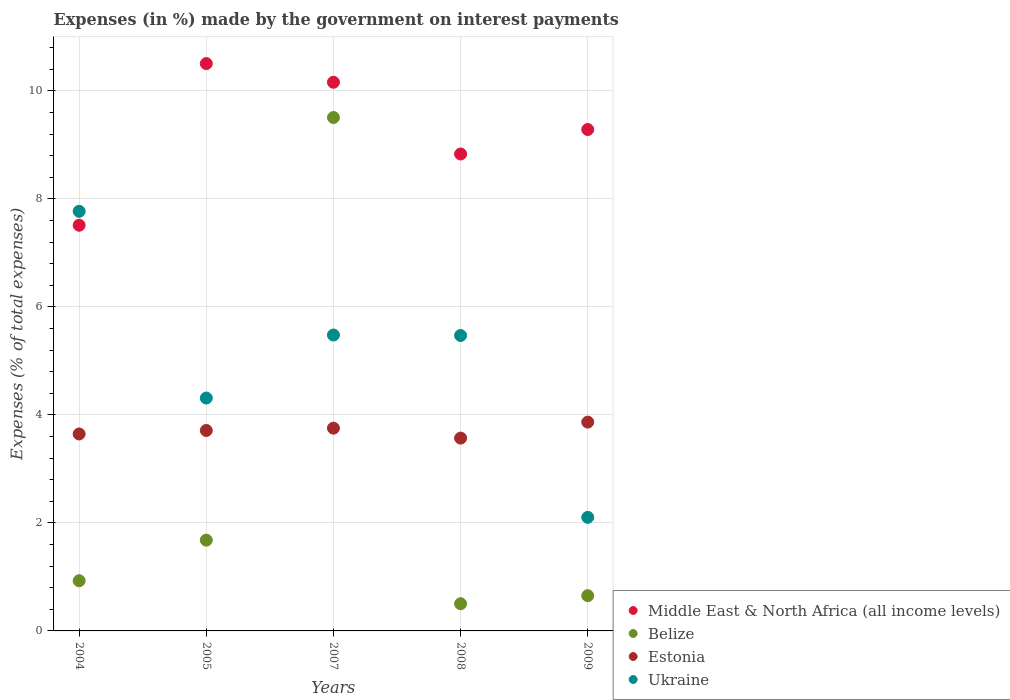Is the number of dotlines equal to the number of legend labels?
Provide a short and direct response. Yes. What is the percentage of expenses made by the government on interest payments in Ukraine in 2005?
Offer a very short reply. 4.31. Across all years, what is the maximum percentage of expenses made by the government on interest payments in Estonia?
Give a very brief answer. 3.87. Across all years, what is the minimum percentage of expenses made by the government on interest payments in Estonia?
Your response must be concise. 3.57. What is the total percentage of expenses made by the government on interest payments in Ukraine in the graph?
Offer a very short reply. 25.13. What is the difference between the percentage of expenses made by the government on interest payments in Belize in 2004 and that in 2009?
Your answer should be compact. 0.28. What is the difference between the percentage of expenses made by the government on interest payments in Ukraine in 2004 and the percentage of expenses made by the government on interest payments in Belize in 2008?
Your response must be concise. 7.27. What is the average percentage of expenses made by the government on interest payments in Ukraine per year?
Ensure brevity in your answer.  5.03. In the year 2005, what is the difference between the percentage of expenses made by the government on interest payments in Estonia and percentage of expenses made by the government on interest payments in Middle East & North Africa (all income levels)?
Your response must be concise. -6.79. What is the ratio of the percentage of expenses made by the government on interest payments in Estonia in 2005 to that in 2009?
Provide a succinct answer. 0.96. Is the percentage of expenses made by the government on interest payments in Ukraine in 2007 less than that in 2009?
Keep it short and to the point. No. What is the difference between the highest and the second highest percentage of expenses made by the government on interest payments in Estonia?
Give a very brief answer. 0.11. What is the difference between the highest and the lowest percentage of expenses made by the government on interest payments in Ukraine?
Your answer should be compact. 5.67. In how many years, is the percentage of expenses made by the government on interest payments in Belize greater than the average percentage of expenses made by the government on interest payments in Belize taken over all years?
Provide a short and direct response. 1. Is it the case that in every year, the sum of the percentage of expenses made by the government on interest payments in Middle East & North Africa (all income levels) and percentage of expenses made by the government on interest payments in Estonia  is greater than the sum of percentage of expenses made by the government on interest payments in Ukraine and percentage of expenses made by the government on interest payments in Belize?
Give a very brief answer. No. Is it the case that in every year, the sum of the percentage of expenses made by the government on interest payments in Belize and percentage of expenses made by the government on interest payments in Ukraine  is greater than the percentage of expenses made by the government on interest payments in Middle East & North Africa (all income levels)?
Ensure brevity in your answer.  No. Is the percentage of expenses made by the government on interest payments in Middle East & North Africa (all income levels) strictly greater than the percentage of expenses made by the government on interest payments in Ukraine over the years?
Make the answer very short. No. Is the percentage of expenses made by the government on interest payments in Belize strictly less than the percentage of expenses made by the government on interest payments in Middle East & North Africa (all income levels) over the years?
Your answer should be very brief. Yes. How many dotlines are there?
Your response must be concise. 4. How many years are there in the graph?
Offer a terse response. 5. What is the difference between two consecutive major ticks on the Y-axis?
Make the answer very short. 2. Are the values on the major ticks of Y-axis written in scientific E-notation?
Your answer should be compact. No. Where does the legend appear in the graph?
Your answer should be very brief. Bottom right. How are the legend labels stacked?
Give a very brief answer. Vertical. What is the title of the graph?
Ensure brevity in your answer.  Expenses (in %) made by the government on interest payments. What is the label or title of the X-axis?
Offer a terse response. Years. What is the label or title of the Y-axis?
Your response must be concise. Expenses (% of total expenses). What is the Expenses (% of total expenses) in Middle East & North Africa (all income levels) in 2004?
Ensure brevity in your answer.  7.51. What is the Expenses (% of total expenses) in Belize in 2004?
Your response must be concise. 0.93. What is the Expenses (% of total expenses) in Estonia in 2004?
Your answer should be very brief. 3.65. What is the Expenses (% of total expenses) in Ukraine in 2004?
Your response must be concise. 7.77. What is the Expenses (% of total expenses) of Middle East & North Africa (all income levels) in 2005?
Your answer should be very brief. 10.5. What is the Expenses (% of total expenses) of Belize in 2005?
Provide a succinct answer. 1.68. What is the Expenses (% of total expenses) of Estonia in 2005?
Make the answer very short. 3.71. What is the Expenses (% of total expenses) in Ukraine in 2005?
Provide a succinct answer. 4.31. What is the Expenses (% of total expenses) of Middle East & North Africa (all income levels) in 2007?
Your response must be concise. 10.16. What is the Expenses (% of total expenses) of Belize in 2007?
Your response must be concise. 9.51. What is the Expenses (% of total expenses) of Estonia in 2007?
Provide a succinct answer. 3.75. What is the Expenses (% of total expenses) in Ukraine in 2007?
Offer a terse response. 5.48. What is the Expenses (% of total expenses) in Middle East & North Africa (all income levels) in 2008?
Provide a succinct answer. 8.83. What is the Expenses (% of total expenses) in Belize in 2008?
Your response must be concise. 0.5. What is the Expenses (% of total expenses) of Estonia in 2008?
Your response must be concise. 3.57. What is the Expenses (% of total expenses) in Ukraine in 2008?
Your answer should be compact. 5.47. What is the Expenses (% of total expenses) in Middle East & North Africa (all income levels) in 2009?
Give a very brief answer. 9.28. What is the Expenses (% of total expenses) in Belize in 2009?
Make the answer very short. 0.65. What is the Expenses (% of total expenses) of Estonia in 2009?
Your answer should be compact. 3.87. What is the Expenses (% of total expenses) in Ukraine in 2009?
Your response must be concise. 2.1. Across all years, what is the maximum Expenses (% of total expenses) of Middle East & North Africa (all income levels)?
Make the answer very short. 10.5. Across all years, what is the maximum Expenses (% of total expenses) of Belize?
Make the answer very short. 9.51. Across all years, what is the maximum Expenses (% of total expenses) of Estonia?
Keep it short and to the point. 3.87. Across all years, what is the maximum Expenses (% of total expenses) of Ukraine?
Ensure brevity in your answer.  7.77. Across all years, what is the minimum Expenses (% of total expenses) in Middle East & North Africa (all income levels)?
Your response must be concise. 7.51. Across all years, what is the minimum Expenses (% of total expenses) of Belize?
Offer a very short reply. 0.5. Across all years, what is the minimum Expenses (% of total expenses) of Estonia?
Your answer should be very brief. 3.57. Across all years, what is the minimum Expenses (% of total expenses) of Ukraine?
Provide a succinct answer. 2.1. What is the total Expenses (% of total expenses) of Middle East & North Africa (all income levels) in the graph?
Make the answer very short. 46.29. What is the total Expenses (% of total expenses) of Belize in the graph?
Your answer should be very brief. 13.27. What is the total Expenses (% of total expenses) of Estonia in the graph?
Give a very brief answer. 18.55. What is the total Expenses (% of total expenses) in Ukraine in the graph?
Your answer should be very brief. 25.13. What is the difference between the Expenses (% of total expenses) in Middle East & North Africa (all income levels) in 2004 and that in 2005?
Offer a terse response. -2.99. What is the difference between the Expenses (% of total expenses) of Belize in 2004 and that in 2005?
Your answer should be very brief. -0.75. What is the difference between the Expenses (% of total expenses) of Estonia in 2004 and that in 2005?
Give a very brief answer. -0.06. What is the difference between the Expenses (% of total expenses) in Ukraine in 2004 and that in 2005?
Your answer should be compact. 3.46. What is the difference between the Expenses (% of total expenses) in Middle East & North Africa (all income levels) in 2004 and that in 2007?
Your answer should be very brief. -2.65. What is the difference between the Expenses (% of total expenses) of Belize in 2004 and that in 2007?
Offer a terse response. -8.58. What is the difference between the Expenses (% of total expenses) in Estonia in 2004 and that in 2007?
Your answer should be very brief. -0.11. What is the difference between the Expenses (% of total expenses) of Ukraine in 2004 and that in 2007?
Offer a terse response. 2.29. What is the difference between the Expenses (% of total expenses) in Middle East & North Africa (all income levels) in 2004 and that in 2008?
Keep it short and to the point. -1.32. What is the difference between the Expenses (% of total expenses) in Belize in 2004 and that in 2008?
Offer a terse response. 0.43. What is the difference between the Expenses (% of total expenses) of Estonia in 2004 and that in 2008?
Your response must be concise. 0.08. What is the difference between the Expenses (% of total expenses) of Ukraine in 2004 and that in 2008?
Your response must be concise. 2.3. What is the difference between the Expenses (% of total expenses) in Middle East & North Africa (all income levels) in 2004 and that in 2009?
Ensure brevity in your answer.  -1.77. What is the difference between the Expenses (% of total expenses) of Belize in 2004 and that in 2009?
Offer a terse response. 0.28. What is the difference between the Expenses (% of total expenses) in Estonia in 2004 and that in 2009?
Offer a very short reply. -0.22. What is the difference between the Expenses (% of total expenses) in Ukraine in 2004 and that in 2009?
Your response must be concise. 5.67. What is the difference between the Expenses (% of total expenses) of Middle East & North Africa (all income levels) in 2005 and that in 2007?
Your answer should be very brief. 0.35. What is the difference between the Expenses (% of total expenses) of Belize in 2005 and that in 2007?
Offer a terse response. -7.83. What is the difference between the Expenses (% of total expenses) in Estonia in 2005 and that in 2007?
Your answer should be compact. -0.04. What is the difference between the Expenses (% of total expenses) of Ukraine in 2005 and that in 2007?
Your answer should be compact. -1.17. What is the difference between the Expenses (% of total expenses) of Middle East & North Africa (all income levels) in 2005 and that in 2008?
Your answer should be compact. 1.67. What is the difference between the Expenses (% of total expenses) of Belize in 2005 and that in 2008?
Ensure brevity in your answer.  1.18. What is the difference between the Expenses (% of total expenses) in Estonia in 2005 and that in 2008?
Provide a succinct answer. 0.14. What is the difference between the Expenses (% of total expenses) of Ukraine in 2005 and that in 2008?
Keep it short and to the point. -1.16. What is the difference between the Expenses (% of total expenses) in Middle East & North Africa (all income levels) in 2005 and that in 2009?
Offer a very short reply. 1.22. What is the difference between the Expenses (% of total expenses) of Belize in 2005 and that in 2009?
Provide a succinct answer. 1.03. What is the difference between the Expenses (% of total expenses) in Estonia in 2005 and that in 2009?
Provide a succinct answer. -0.15. What is the difference between the Expenses (% of total expenses) in Ukraine in 2005 and that in 2009?
Give a very brief answer. 2.21. What is the difference between the Expenses (% of total expenses) in Middle East & North Africa (all income levels) in 2007 and that in 2008?
Give a very brief answer. 1.33. What is the difference between the Expenses (% of total expenses) in Belize in 2007 and that in 2008?
Give a very brief answer. 9. What is the difference between the Expenses (% of total expenses) of Estonia in 2007 and that in 2008?
Your answer should be compact. 0.18. What is the difference between the Expenses (% of total expenses) in Ukraine in 2007 and that in 2008?
Provide a short and direct response. 0.01. What is the difference between the Expenses (% of total expenses) of Middle East & North Africa (all income levels) in 2007 and that in 2009?
Offer a terse response. 0.87. What is the difference between the Expenses (% of total expenses) of Belize in 2007 and that in 2009?
Give a very brief answer. 8.85. What is the difference between the Expenses (% of total expenses) of Estonia in 2007 and that in 2009?
Provide a short and direct response. -0.11. What is the difference between the Expenses (% of total expenses) of Ukraine in 2007 and that in 2009?
Make the answer very short. 3.38. What is the difference between the Expenses (% of total expenses) of Middle East & North Africa (all income levels) in 2008 and that in 2009?
Keep it short and to the point. -0.45. What is the difference between the Expenses (% of total expenses) of Belize in 2008 and that in 2009?
Make the answer very short. -0.15. What is the difference between the Expenses (% of total expenses) in Estonia in 2008 and that in 2009?
Keep it short and to the point. -0.3. What is the difference between the Expenses (% of total expenses) in Ukraine in 2008 and that in 2009?
Your answer should be very brief. 3.37. What is the difference between the Expenses (% of total expenses) of Middle East & North Africa (all income levels) in 2004 and the Expenses (% of total expenses) of Belize in 2005?
Make the answer very short. 5.83. What is the difference between the Expenses (% of total expenses) of Middle East & North Africa (all income levels) in 2004 and the Expenses (% of total expenses) of Estonia in 2005?
Provide a succinct answer. 3.8. What is the difference between the Expenses (% of total expenses) in Middle East & North Africa (all income levels) in 2004 and the Expenses (% of total expenses) in Ukraine in 2005?
Ensure brevity in your answer.  3.2. What is the difference between the Expenses (% of total expenses) in Belize in 2004 and the Expenses (% of total expenses) in Estonia in 2005?
Offer a very short reply. -2.78. What is the difference between the Expenses (% of total expenses) of Belize in 2004 and the Expenses (% of total expenses) of Ukraine in 2005?
Give a very brief answer. -3.38. What is the difference between the Expenses (% of total expenses) of Estonia in 2004 and the Expenses (% of total expenses) of Ukraine in 2005?
Make the answer very short. -0.67. What is the difference between the Expenses (% of total expenses) of Middle East & North Africa (all income levels) in 2004 and the Expenses (% of total expenses) of Belize in 2007?
Keep it short and to the point. -1.99. What is the difference between the Expenses (% of total expenses) of Middle East & North Africa (all income levels) in 2004 and the Expenses (% of total expenses) of Estonia in 2007?
Your answer should be compact. 3.76. What is the difference between the Expenses (% of total expenses) of Middle East & North Africa (all income levels) in 2004 and the Expenses (% of total expenses) of Ukraine in 2007?
Your answer should be compact. 2.03. What is the difference between the Expenses (% of total expenses) in Belize in 2004 and the Expenses (% of total expenses) in Estonia in 2007?
Provide a short and direct response. -2.82. What is the difference between the Expenses (% of total expenses) in Belize in 2004 and the Expenses (% of total expenses) in Ukraine in 2007?
Offer a terse response. -4.55. What is the difference between the Expenses (% of total expenses) in Estonia in 2004 and the Expenses (% of total expenses) in Ukraine in 2007?
Provide a short and direct response. -1.83. What is the difference between the Expenses (% of total expenses) in Middle East & North Africa (all income levels) in 2004 and the Expenses (% of total expenses) in Belize in 2008?
Keep it short and to the point. 7.01. What is the difference between the Expenses (% of total expenses) in Middle East & North Africa (all income levels) in 2004 and the Expenses (% of total expenses) in Estonia in 2008?
Your answer should be very brief. 3.94. What is the difference between the Expenses (% of total expenses) in Middle East & North Africa (all income levels) in 2004 and the Expenses (% of total expenses) in Ukraine in 2008?
Ensure brevity in your answer.  2.04. What is the difference between the Expenses (% of total expenses) of Belize in 2004 and the Expenses (% of total expenses) of Estonia in 2008?
Provide a succinct answer. -2.64. What is the difference between the Expenses (% of total expenses) of Belize in 2004 and the Expenses (% of total expenses) of Ukraine in 2008?
Offer a very short reply. -4.54. What is the difference between the Expenses (% of total expenses) in Estonia in 2004 and the Expenses (% of total expenses) in Ukraine in 2008?
Ensure brevity in your answer.  -1.82. What is the difference between the Expenses (% of total expenses) in Middle East & North Africa (all income levels) in 2004 and the Expenses (% of total expenses) in Belize in 2009?
Your response must be concise. 6.86. What is the difference between the Expenses (% of total expenses) in Middle East & North Africa (all income levels) in 2004 and the Expenses (% of total expenses) in Estonia in 2009?
Make the answer very short. 3.65. What is the difference between the Expenses (% of total expenses) of Middle East & North Africa (all income levels) in 2004 and the Expenses (% of total expenses) of Ukraine in 2009?
Your answer should be compact. 5.41. What is the difference between the Expenses (% of total expenses) of Belize in 2004 and the Expenses (% of total expenses) of Estonia in 2009?
Your response must be concise. -2.94. What is the difference between the Expenses (% of total expenses) in Belize in 2004 and the Expenses (% of total expenses) in Ukraine in 2009?
Your answer should be very brief. -1.17. What is the difference between the Expenses (% of total expenses) in Estonia in 2004 and the Expenses (% of total expenses) in Ukraine in 2009?
Offer a terse response. 1.54. What is the difference between the Expenses (% of total expenses) of Middle East & North Africa (all income levels) in 2005 and the Expenses (% of total expenses) of Belize in 2007?
Provide a short and direct response. 1. What is the difference between the Expenses (% of total expenses) in Middle East & North Africa (all income levels) in 2005 and the Expenses (% of total expenses) in Estonia in 2007?
Your answer should be very brief. 6.75. What is the difference between the Expenses (% of total expenses) of Middle East & North Africa (all income levels) in 2005 and the Expenses (% of total expenses) of Ukraine in 2007?
Ensure brevity in your answer.  5.03. What is the difference between the Expenses (% of total expenses) of Belize in 2005 and the Expenses (% of total expenses) of Estonia in 2007?
Your response must be concise. -2.07. What is the difference between the Expenses (% of total expenses) of Belize in 2005 and the Expenses (% of total expenses) of Ukraine in 2007?
Give a very brief answer. -3.8. What is the difference between the Expenses (% of total expenses) of Estonia in 2005 and the Expenses (% of total expenses) of Ukraine in 2007?
Your response must be concise. -1.77. What is the difference between the Expenses (% of total expenses) in Middle East & North Africa (all income levels) in 2005 and the Expenses (% of total expenses) in Belize in 2008?
Provide a short and direct response. 10. What is the difference between the Expenses (% of total expenses) in Middle East & North Africa (all income levels) in 2005 and the Expenses (% of total expenses) in Estonia in 2008?
Offer a very short reply. 6.93. What is the difference between the Expenses (% of total expenses) in Middle East & North Africa (all income levels) in 2005 and the Expenses (% of total expenses) in Ukraine in 2008?
Offer a very short reply. 5.03. What is the difference between the Expenses (% of total expenses) in Belize in 2005 and the Expenses (% of total expenses) in Estonia in 2008?
Ensure brevity in your answer.  -1.89. What is the difference between the Expenses (% of total expenses) in Belize in 2005 and the Expenses (% of total expenses) in Ukraine in 2008?
Provide a short and direct response. -3.79. What is the difference between the Expenses (% of total expenses) in Estonia in 2005 and the Expenses (% of total expenses) in Ukraine in 2008?
Offer a very short reply. -1.76. What is the difference between the Expenses (% of total expenses) in Middle East & North Africa (all income levels) in 2005 and the Expenses (% of total expenses) in Belize in 2009?
Your answer should be very brief. 9.85. What is the difference between the Expenses (% of total expenses) in Middle East & North Africa (all income levels) in 2005 and the Expenses (% of total expenses) in Estonia in 2009?
Make the answer very short. 6.64. What is the difference between the Expenses (% of total expenses) of Middle East & North Africa (all income levels) in 2005 and the Expenses (% of total expenses) of Ukraine in 2009?
Keep it short and to the point. 8.4. What is the difference between the Expenses (% of total expenses) in Belize in 2005 and the Expenses (% of total expenses) in Estonia in 2009?
Your answer should be compact. -2.19. What is the difference between the Expenses (% of total expenses) of Belize in 2005 and the Expenses (% of total expenses) of Ukraine in 2009?
Provide a succinct answer. -0.42. What is the difference between the Expenses (% of total expenses) in Estonia in 2005 and the Expenses (% of total expenses) in Ukraine in 2009?
Make the answer very short. 1.61. What is the difference between the Expenses (% of total expenses) of Middle East & North Africa (all income levels) in 2007 and the Expenses (% of total expenses) of Belize in 2008?
Give a very brief answer. 9.65. What is the difference between the Expenses (% of total expenses) of Middle East & North Africa (all income levels) in 2007 and the Expenses (% of total expenses) of Estonia in 2008?
Provide a succinct answer. 6.59. What is the difference between the Expenses (% of total expenses) of Middle East & North Africa (all income levels) in 2007 and the Expenses (% of total expenses) of Ukraine in 2008?
Keep it short and to the point. 4.69. What is the difference between the Expenses (% of total expenses) in Belize in 2007 and the Expenses (% of total expenses) in Estonia in 2008?
Make the answer very short. 5.94. What is the difference between the Expenses (% of total expenses) of Belize in 2007 and the Expenses (% of total expenses) of Ukraine in 2008?
Your answer should be compact. 4.04. What is the difference between the Expenses (% of total expenses) of Estonia in 2007 and the Expenses (% of total expenses) of Ukraine in 2008?
Ensure brevity in your answer.  -1.72. What is the difference between the Expenses (% of total expenses) of Middle East & North Africa (all income levels) in 2007 and the Expenses (% of total expenses) of Belize in 2009?
Provide a succinct answer. 9.51. What is the difference between the Expenses (% of total expenses) of Middle East & North Africa (all income levels) in 2007 and the Expenses (% of total expenses) of Estonia in 2009?
Give a very brief answer. 6.29. What is the difference between the Expenses (% of total expenses) in Middle East & North Africa (all income levels) in 2007 and the Expenses (% of total expenses) in Ukraine in 2009?
Offer a terse response. 8.06. What is the difference between the Expenses (% of total expenses) in Belize in 2007 and the Expenses (% of total expenses) in Estonia in 2009?
Give a very brief answer. 5.64. What is the difference between the Expenses (% of total expenses) of Belize in 2007 and the Expenses (% of total expenses) of Ukraine in 2009?
Make the answer very short. 7.4. What is the difference between the Expenses (% of total expenses) in Estonia in 2007 and the Expenses (% of total expenses) in Ukraine in 2009?
Your answer should be very brief. 1.65. What is the difference between the Expenses (% of total expenses) of Middle East & North Africa (all income levels) in 2008 and the Expenses (% of total expenses) of Belize in 2009?
Provide a short and direct response. 8.18. What is the difference between the Expenses (% of total expenses) in Middle East & North Africa (all income levels) in 2008 and the Expenses (% of total expenses) in Estonia in 2009?
Provide a short and direct response. 4.96. What is the difference between the Expenses (% of total expenses) in Middle East & North Africa (all income levels) in 2008 and the Expenses (% of total expenses) in Ukraine in 2009?
Make the answer very short. 6.73. What is the difference between the Expenses (% of total expenses) in Belize in 2008 and the Expenses (% of total expenses) in Estonia in 2009?
Ensure brevity in your answer.  -3.36. What is the difference between the Expenses (% of total expenses) of Belize in 2008 and the Expenses (% of total expenses) of Ukraine in 2009?
Ensure brevity in your answer.  -1.6. What is the difference between the Expenses (% of total expenses) of Estonia in 2008 and the Expenses (% of total expenses) of Ukraine in 2009?
Your answer should be very brief. 1.47. What is the average Expenses (% of total expenses) in Middle East & North Africa (all income levels) per year?
Keep it short and to the point. 9.26. What is the average Expenses (% of total expenses) of Belize per year?
Provide a short and direct response. 2.65. What is the average Expenses (% of total expenses) of Estonia per year?
Your answer should be very brief. 3.71. What is the average Expenses (% of total expenses) in Ukraine per year?
Your response must be concise. 5.03. In the year 2004, what is the difference between the Expenses (% of total expenses) in Middle East & North Africa (all income levels) and Expenses (% of total expenses) in Belize?
Offer a terse response. 6.58. In the year 2004, what is the difference between the Expenses (% of total expenses) in Middle East & North Africa (all income levels) and Expenses (% of total expenses) in Estonia?
Your response must be concise. 3.86. In the year 2004, what is the difference between the Expenses (% of total expenses) in Middle East & North Africa (all income levels) and Expenses (% of total expenses) in Ukraine?
Provide a short and direct response. -0.26. In the year 2004, what is the difference between the Expenses (% of total expenses) in Belize and Expenses (% of total expenses) in Estonia?
Offer a very short reply. -2.72. In the year 2004, what is the difference between the Expenses (% of total expenses) in Belize and Expenses (% of total expenses) in Ukraine?
Give a very brief answer. -6.84. In the year 2004, what is the difference between the Expenses (% of total expenses) in Estonia and Expenses (% of total expenses) in Ukraine?
Ensure brevity in your answer.  -4.12. In the year 2005, what is the difference between the Expenses (% of total expenses) of Middle East & North Africa (all income levels) and Expenses (% of total expenses) of Belize?
Your response must be concise. 8.82. In the year 2005, what is the difference between the Expenses (% of total expenses) in Middle East & North Africa (all income levels) and Expenses (% of total expenses) in Estonia?
Give a very brief answer. 6.79. In the year 2005, what is the difference between the Expenses (% of total expenses) of Middle East & North Africa (all income levels) and Expenses (% of total expenses) of Ukraine?
Your answer should be very brief. 6.19. In the year 2005, what is the difference between the Expenses (% of total expenses) in Belize and Expenses (% of total expenses) in Estonia?
Give a very brief answer. -2.03. In the year 2005, what is the difference between the Expenses (% of total expenses) in Belize and Expenses (% of total expenses) in Ukraine?
Give a very brief answer. -2.63. In the year 2005, what is the difference between the Expenses (% of total expenses) in Estonia and Expenses (% of total expenses) in Ukraine?
Give a very brief answer. -0.6. In the year 2007, what is the difference between the Expenses (% of total expenses) of Middle East & North Africa (all income levels) and Expenses (% of total expenses) of Belize?
Make the answer very short. 0.65. In the year 2007, what is the difference between the Expenses (% of total expenses) in Middle East & North Africa (all income levels) and Expenses (% of total expenses) in Estonia?
Ensure brevity in your answer.  6.4. In the year 2007, what is the difference between the Expenses (% of total expenses) of Middle East & North Africa (all income levels) and Expenses (% of total expenses) of Ukraine?
Offer a terse response. 4.68. In the year 2007, what is the difference between the Expenses (% of total expenses) in Belize and Expenses (% of total expenses) in Estonia?
Your answer should be compact. 5.75. In the year 2007, what is the difference between the Expenses (% of total expenses) of Belize and Expenses (% of total expenses) of Ukraine?
Give a very brief answer. 4.03. In the year 2007, what is the difference between the Expenses (% of total expenses) of Estonia and Expenses (% of total expenses) of Ukraine?
Your response must be concise. -1.72. In the year 2008, what is the difference between the Expenses (% of total expenses) in Middle East & North Africa (all income levels) and Expenses (% of total expenses) in Belize?
Give a very brief answer. 8.33. In the year 2008, what is the difference between the Expenses (% of total expenses) of Middle East & North Africa (all income levels) and Expenses (% of total expenses) of Estonia?
Your response must be concise. 5.26. In the year 2008, what is the difference between the Expenses (% of total expenses) in Middle East & North Africa (all income levels) and Expenses (% of total expenses) in Ukraine?
Offer a very short reply. 3.36. In the year 2008, what is the difference between the Expenses (% of total expenses) of Belize and Expenses (% of total expenses) of Estonia?
Keep it short and to the point. -3.07. In the year 2008, what is the difference between the Expenses (% of total expenses) of Belize and Expenses (% of total expenses) of Ukraine?
Make the answer very short. -4.97. In the year 2008, what is the difference between the Expenses (% of total expenses) of Estonia and Expenses (% of total expenses) of Ukraine?
Make the answer very short. -1.9. In the year 2009, what is the difference between the Expenses (% of total expenses) of Middle East & North Africa (all income levels) and Expenses (% of total expenses) of Belize?
Your response must be concise. 8.63. In the year 2009, what is the difference between the Expenses (% of total expenses) in Middle East & North Africa (all income levels) and Expenses (% of total expenses) in Estonia?
Your answer should be very brief. 5.42. In the year 2009, what is the difference between the Expenses (% of total expenses) of Middle East & North Africa (all income levels) and Expenses (% of total expenses) of Ukraine?
Give a very brief answer. 7.18. In the year 2009, what is the difference between the Expenses (% of total expenses) in Belize and Expenses (% of total expenses) in Estonia?
Your answer should be very brief. -3.21. In the year 2009, what is the difference between the Expenses (% of total expenses) in Belize and Expenses (% of total expenses) in Ukraine?
Give a very brief answer. -1.45. In the year 2009, what is the difference between the Expenses (% of total expenses) of Estonia and Expenses (% of total expenses) of Ukraine?
Offer a terse response. 1.76. What is the ratio of the Expenses (% of total expenses) in Middle East & North Africa (all income levels) in 2004 to that in 2005?
Offer a very short reply. 0.72. What is the ratio of the Expenses (% of total expenses) in Belize in 2004 to that in 2005?
Give a very brief answer. 0.55. What is the ratio of the Expenses (% of total expenses) of Estonia in 2004 to that in 2005?
Give a very brief answer. 0.98. What is the ratio of the Expenses (% of total expenses) in Ukraine in 2004 to that in 2005?
Provide a succinct answer. 1.8. What is the ratio of the Expenses (% of total expenses) of Middle East & North Africa (all income levels) in 2004 to that in 2007?
Your answer should be very brief. 0.74. What is the ratio of the Expenses (% of total expenses) of Belize in 2004 to that in 2007?
Provide a short and direct response. 0.1. What is the ratio of the Expenses (% of total expenses) in Estonia in 2004 to that in 2007?
Make the answer very short. 0.97. What is the ratio of the Expenses (% of total expenses) in Ukraine in 2004 to that in 2007?
Your response must be concise. 1.42. What is the ratio of the Expenses (% of total expenses) of Middle East & North Africa (all income levels) in 2004 to that in 2008?
Keep it short and to the point. 0.85. What is the ratio of the Expenses (% of total expenses) in Belize in 2004 to that in 2008?
Offer a terse response. 1.85. What is the ratio of the Expenses (% of total expenses) of Estonia in 2004 to that in 2008?
Your response must be concise. 1.02. What is the ratio of the Expenses (% of total expenses) of Ukraine in 2004 to that in 2008?
Make the answer very short. 1.42. What is the ratio of the Expenses (% of total expenses) of Middle East & North Africa (all income levels) in 2004 to that in 2009?
Make the answer very short. 0.81. What is the ratio of the Expenses (% of total expenses) in Belize in 2004 to that in 2009?
Your answer should be compact. 1.42. What is the ratio of the Expenses (% of total expenses) of Estonia in 2004 to that in 2009?
Make the answer very short. 0.94. What is the ratio of the Expenses (% of total expenses) of Ukraine in 2004 to that in 2009?
Provide a succinct answer. 3.69. What is the ratio of the Expenses (% of total expenses) in Middle East & North Africa (all income levels) in 2005 to that in 2007?
Your answer should be compact. 1.03. What is the ratio of the Expenses (% of total expenses) of Belize in 2005 to that in 2007?
Provide a succinct answer. 0.18. What is the ratio of the Expenses (% of total expenses) of Estonia in 2005 to that in 2007?
Make the answer very short. 0.99. What is the ratio of the Expenses (% of total expenses) of Ukraine in 2005 to that in 2007?
Provide a succinct answer. 0.79. What is the ratio of the Expenses (% of total expenses) in Middle East & North Africa (all income levels) in 2005 to that in 2008?
Make the answer very short. 1.19. What is the ratio of the Expenses (% of total expenses) of Belize in 2005 to that in 2008?
Keep it short and to the point. 3.34. What is the ratio of the Expenses (% of total expenses) in Estonia in 2005 to that in 2008?
Provide a short and direct response. 1.04. What is the ratio of the Expenses (% of total expenses) in Ukraine in 2005 to that in 2008?
Your response must be concise. 0.79. What is the ratio of the Expenses (% of total expenses) in Middle East & North Africa (all income levels) in 2005 to that in 2009?
Your answer should be compact. 1.13. What is the ratio of the Expenses (% of total expenses) of Belize in 2005 to that in 2009?
Provide a short and direct response. 2.58. What is the ratio of the Expenses (% of total expenses) of Estonia in 2005 to that in 2009?
Keep it short and to the point. 0.96. What is the ratio of the Expenses (% of total expenses) in Ukraine in 2005 to that in 2009?
Your answer should be compact. 2.05. What is the ratio of the Expenses (% of total expenses) in Middle East & North Africa (all income levels) in 2007 to that in 2008?
Keep it short and to the point. 1.15. What is the ratio of the Expenses (% of total expenses) of Belize in 2007 to that in 2008?
Provide a succinct answer. 18.88. What is the ratio of the Expenses (% of total expenses) of Estonia in 2007 to that in 2008?
Keep it short and to the point. 1.05. What is the ratio of the Expenses (% of total expenses) in Middle East & North Africa (all income levels) in 2007 to that in 2009?
Provide a short and direct response. 1.09. What is the ratio of the Expenses (% of total expenses) in Belize in 2007 to that in 2009?
Give a very brief answer. 14.57. What is the ratio of the Expenses (% of total expenses) of Estonia in 2007 to that in 2009?
Make the answer very short. 0.97. What is the ratio of the Expenses (% of total expenses) in Ukraine in 2007 to that in 2009?
Offer a very short reply. 2.6. What is the ratio of the Expenses (% of total expenses) of Middle East & North Africa (all income levels) in 2008 to that in 2009?
Ensure brevity in your answer.  0.95. What is the ratio of the Expenses (% of total expenses) of Belize in 2008 to that in 2009?
Keep it short and to the point. 0.77. What is the ratio of the Expenses (% of total expenses) of Estonia in 2008 to that in 2009?
Your response must be concise. 0.92. What is the ratio of the Expenses (% of total expenses) of Ukraine in 2008 to that in 2009?
Make the answer very short. 2.6. What is the difference between the highest and the second highest Expenses (% of total expenses) of Middle East & North Africa (all income levels)?
Ensure brevity in your answer.  0.35. What is the difference between the highest and the second highest Expenses (% of total expenses) in Belize?
Offer a terse response. 7.83. What is the difference between the highest and the second highest Expenses (% of total expenses) of Estonia?
Keep it short and to the point. 0.11. What is the difference between the highest and the second highest Expenses (% of total expenses) in Ukraine?
Your answer should be compact. 2.29. What is the difference between the highest and the lowest Expenses (% of total expenses) in Middle East & North Africa (all income levels)?
Give a very brief answer. 2.99. What is the difference between the highest and the lowest Expenses (% of total expenses) of Belize?
Give a very brief answer. 9. What is the difference between the highest and the lowest Expenses (% of total expenses) of Estonia?
Make the answer very short. 0.3. What is the difference between the highest and the lowest Expenses (% of total expenses) in Ukraine?
Give a very brief answer. 5.67. 